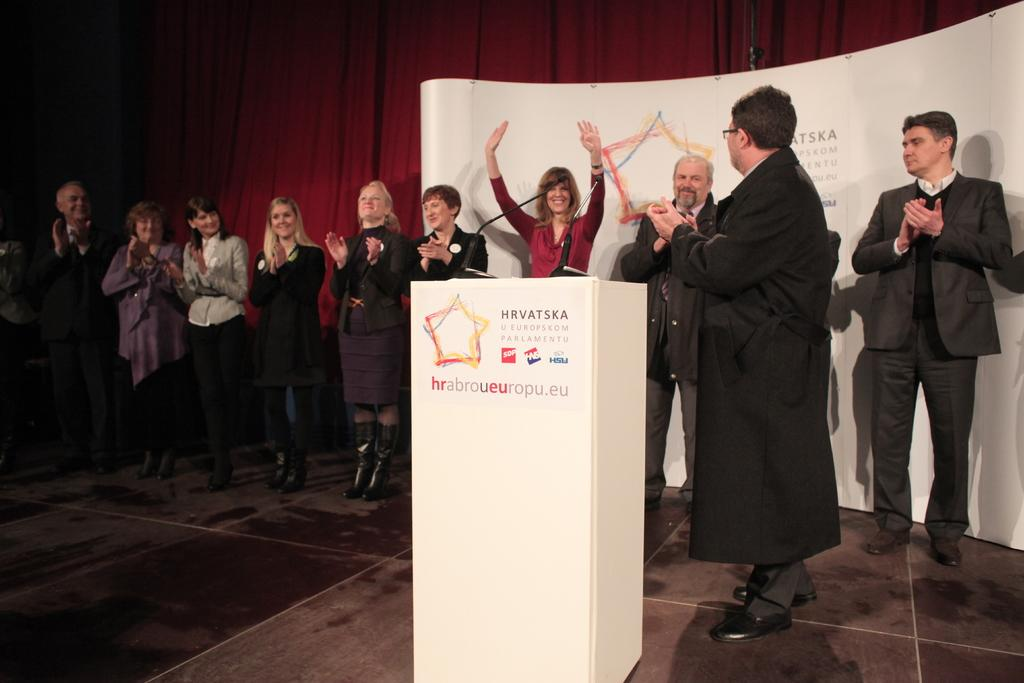What can be seen in the image involving people? There are people standing in the image. What object is present in the image that is typically used for amplifying sound? There is a microphone in the image. What is the purpose of the wooden stand in the image? The wooden stand is likely used to hold or support the microphone. What can be seen in the image that is used for advertising or conveying information? There is a banner/poster in the image. What can be seen in the background of the image that might be used for privacy or decoration? There is a curtain in the background of the image. How does the man breathe underwater in the image? There is no man or underwater scene present in the image. What type of cover is used to protect the microphone from dust in the image? There is no cover visible in the image; only the microphone is present. 